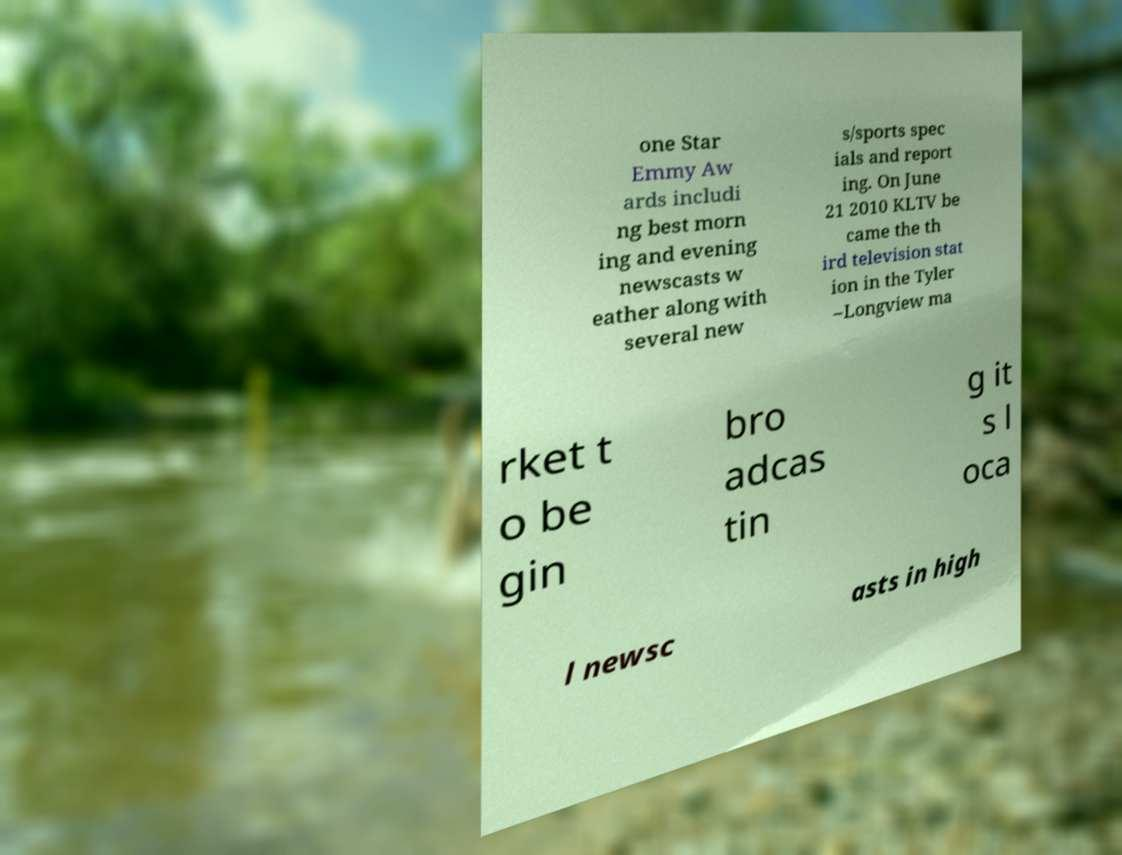Could you assist in decoding the text presented in this image and type it out clearly? one Star Emmy Aw ards includi ng best morn ing and evening newscasts w eather along with several new s/sports spec ials and report ing. On June 21 2010 KLTV be came the th ird television stat ion in the Tyler –Longview ma rket t o be gin bro adcas tin g it s l oca l newsc asts in high 